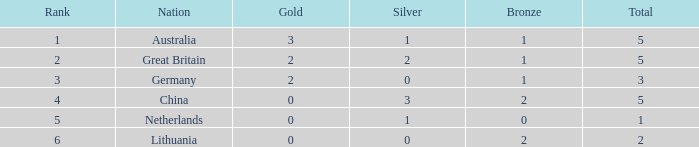What is the median gold when the rank is lesser than 3 and the bronze is lesser than 1? None. 